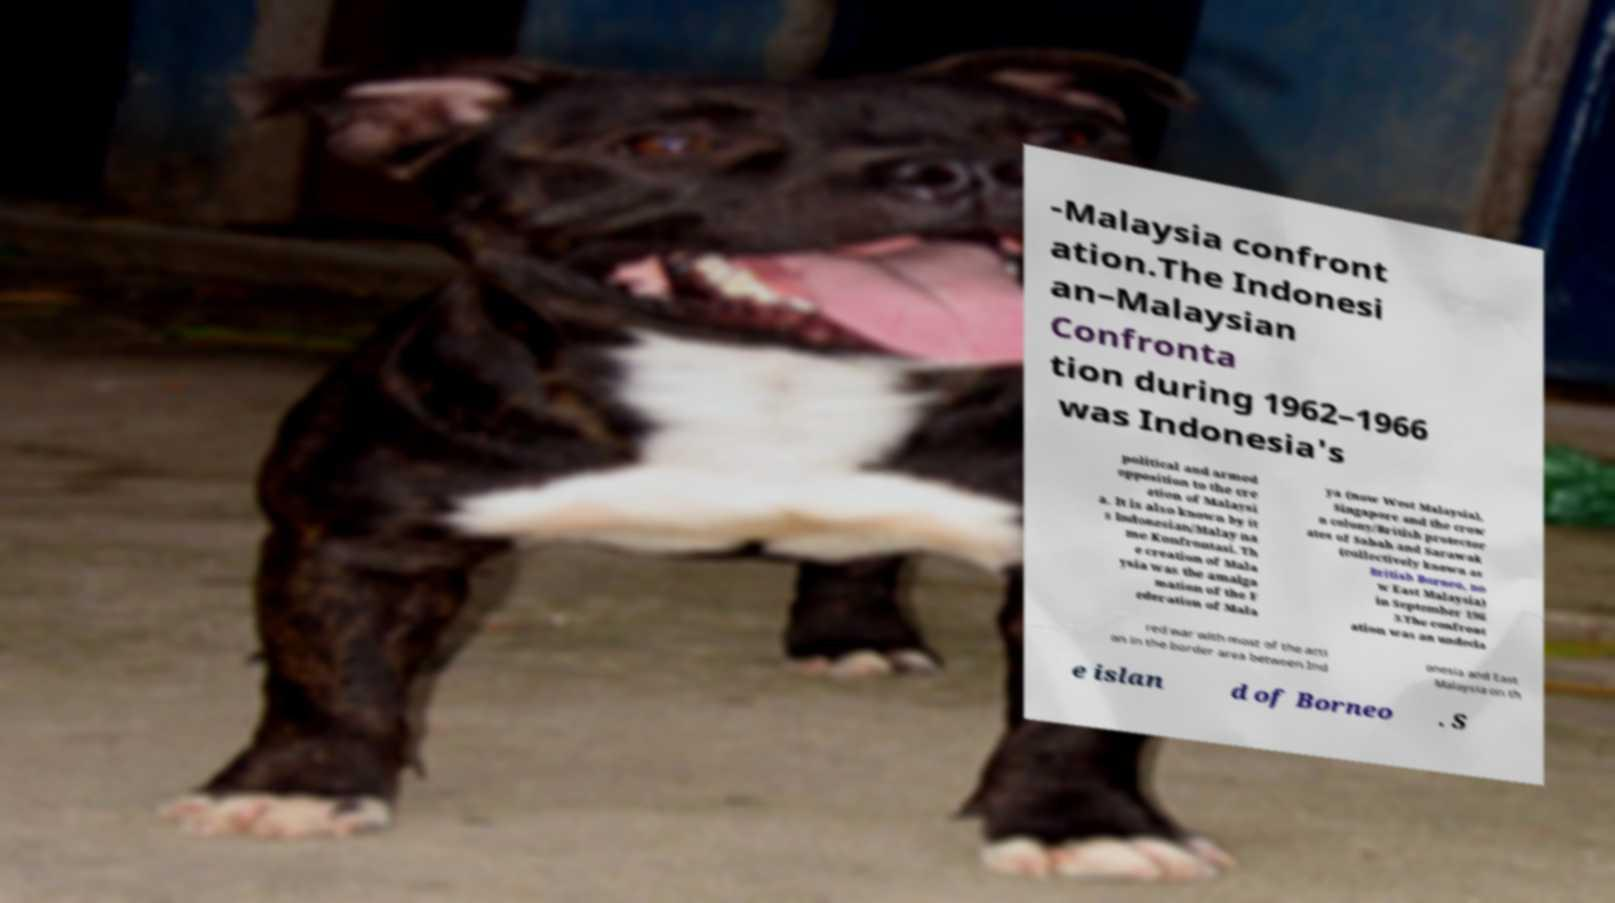Could you extract and type out the text from this image? -Malaysia confront ation.The Indonesi an–Malaysian Confronta tion during 1962–1966 was Indonesia's political and armed opposition to the cre ation of Malaysi a. It is also known by it s Indonesian/Malay na me Konfrontasi. Th e creation of Mala ysia was the amalga mation of the F ederation of Mala ya (now West Malaysia), Singapore and the crow n colony/British protector ates of Sabah and Sarawak (collectively known as British Borneo, no w East Malaysia) in September 196 3.The confront ation was an undecla red war with most of the acti on in the border area between Ind onesia and East Malaysia on th e islan d of Borneo . S 